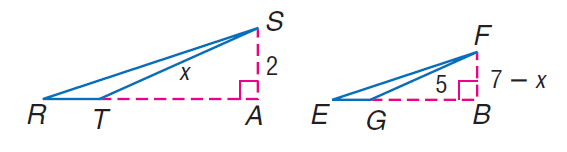Question: Find F B if S A and F B are altitudes and \triangle R S T \sim \triangle E F G.
Choices:
A. 1
B. 2
C. 3
D. 4
Answer with the letter. Answer: B 